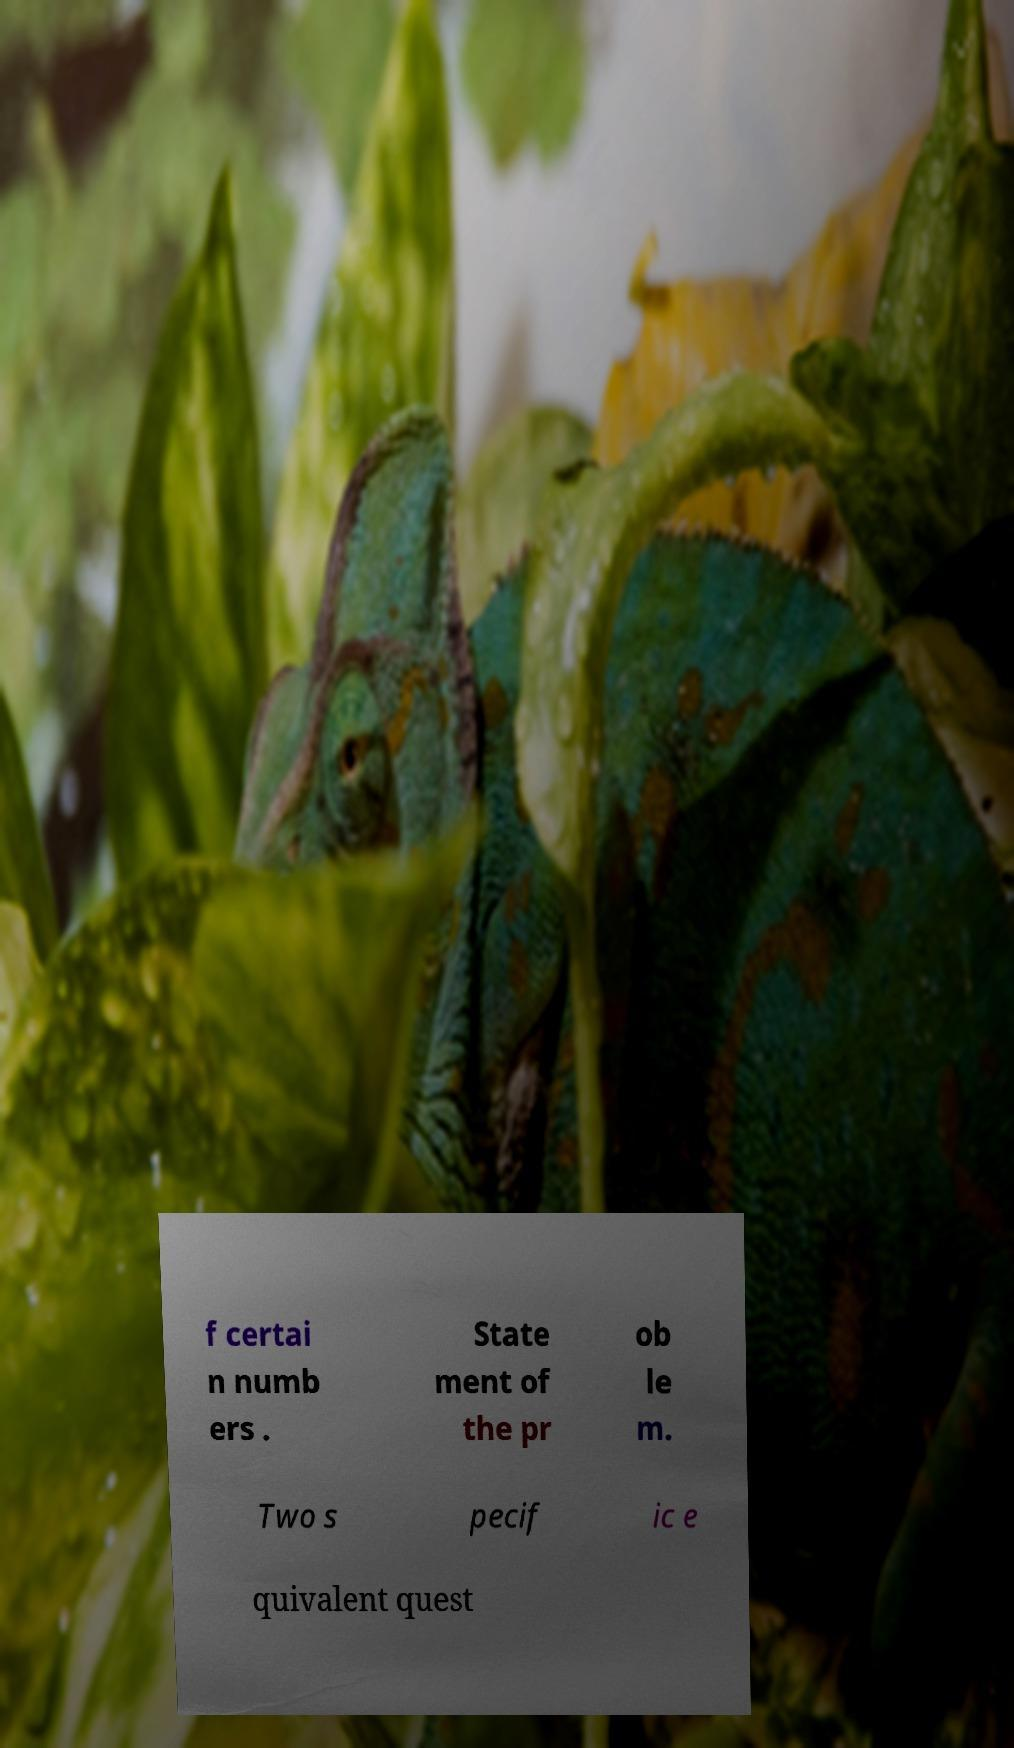What messages or text are displayed in this image? I need them in a readable, typed format. f certai n numb ers . State ment of the pr ob le m. Two s pecif ic e quivalent quest 